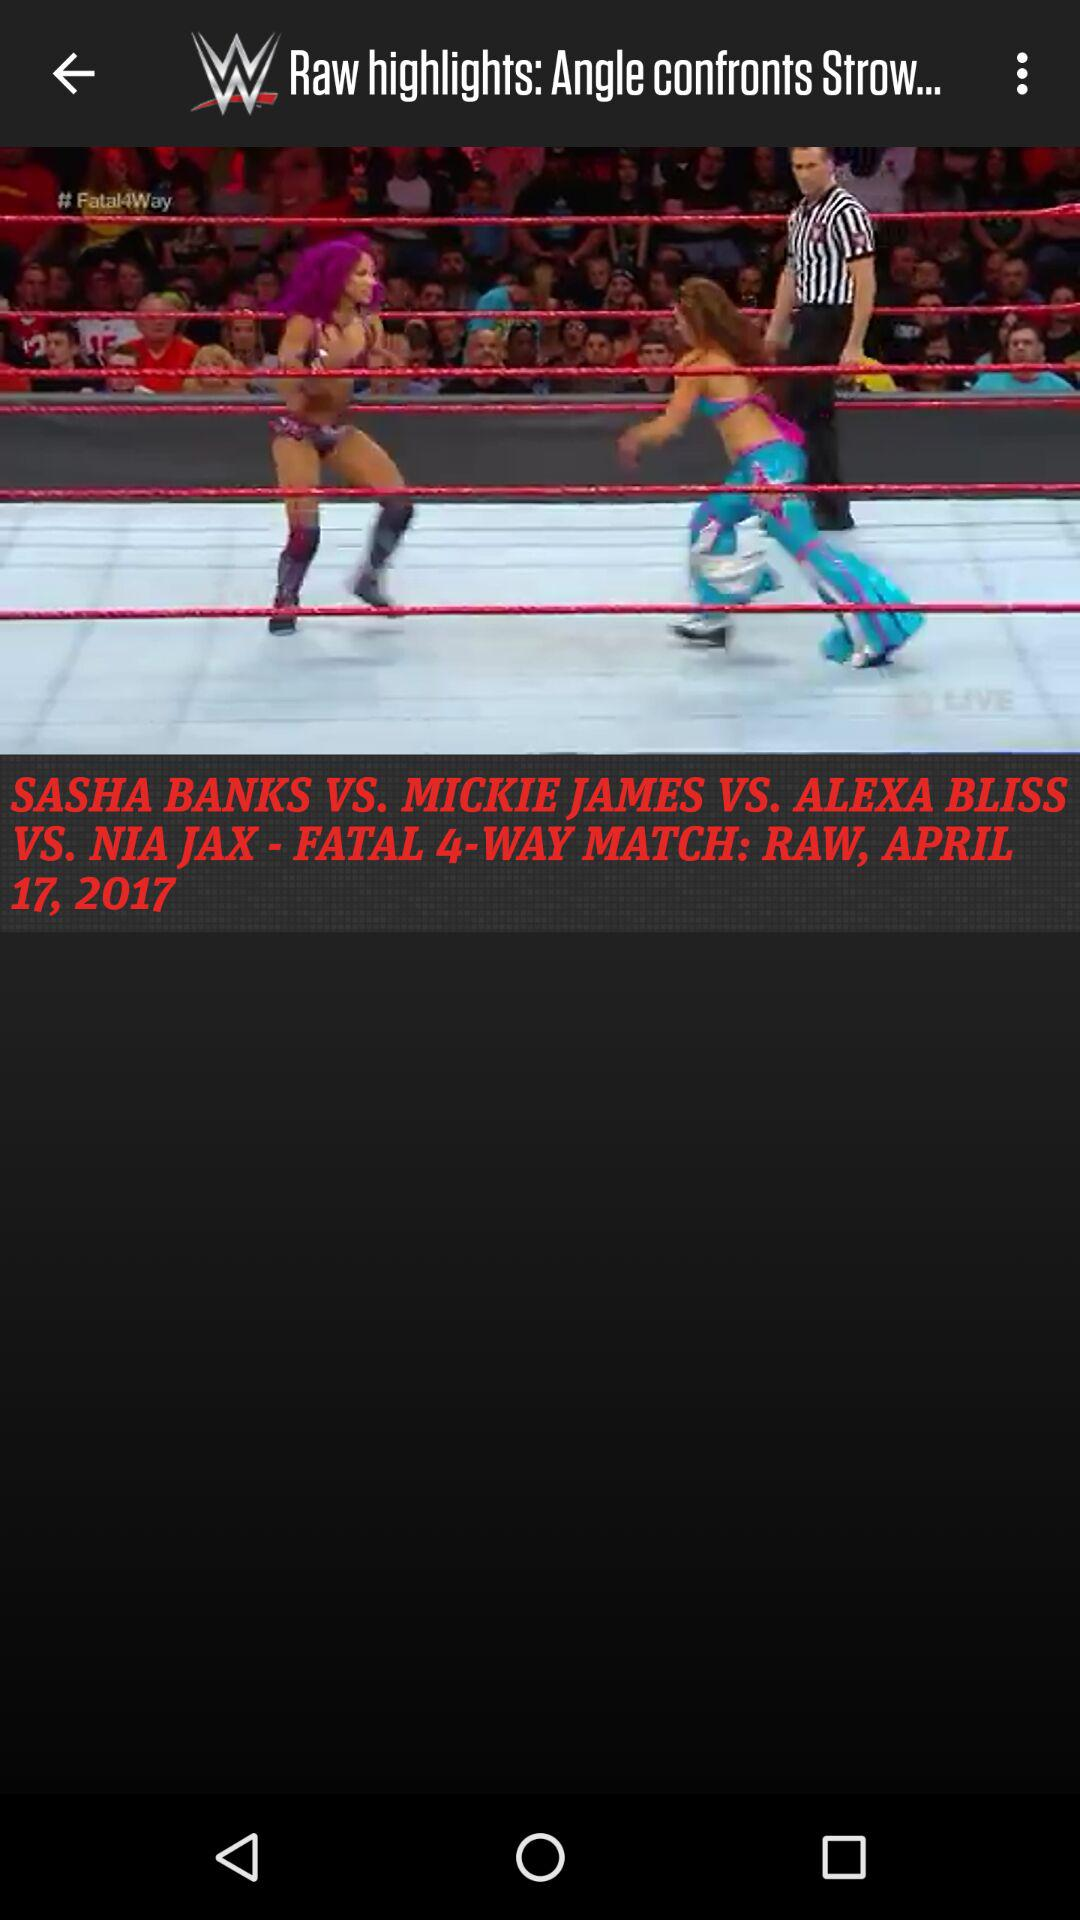What is the date of the match? The date is April 17, 2017. 